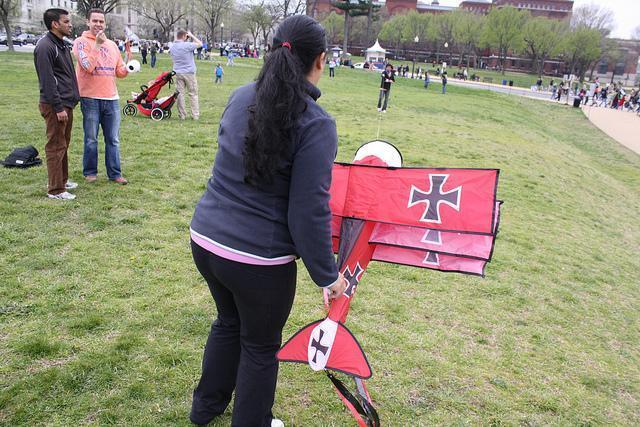How many people are in the picture?
Give a very brief answer. 4. How many chairs are shown?
Give a very brief answer. 0. 